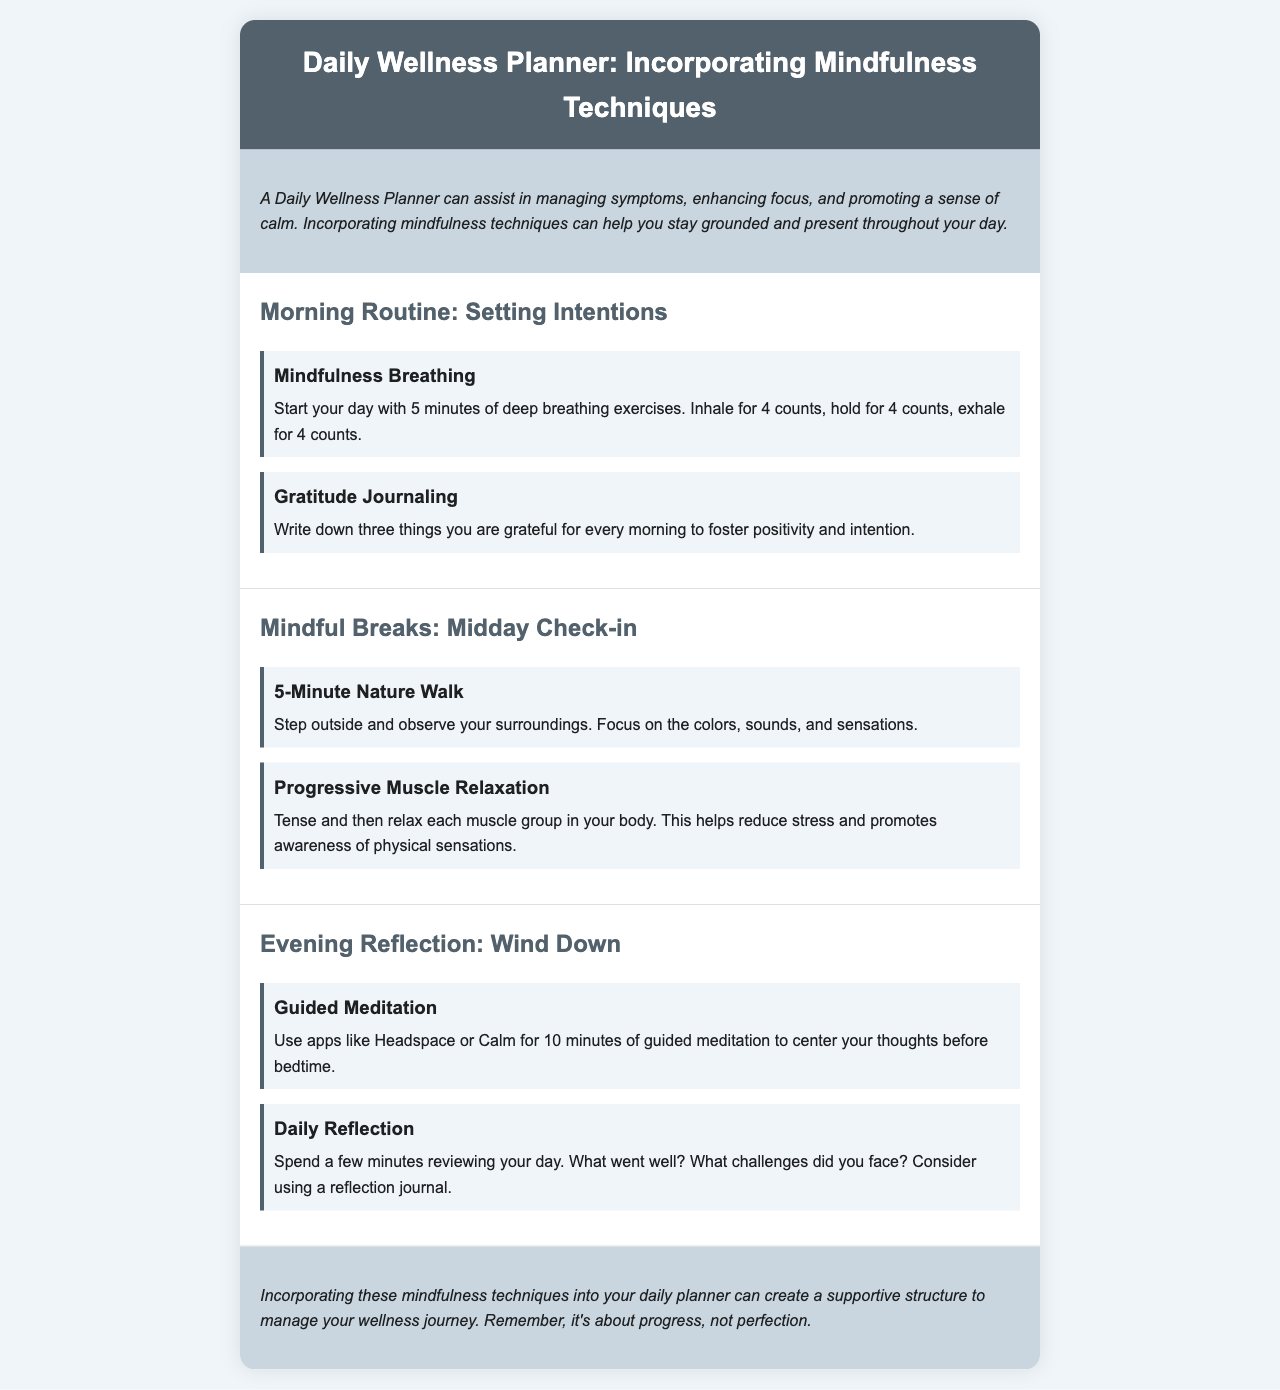What are the two activities included in the Morning Routine? The Morning Routine section lists two activities: Mindfulness Breathing and Gratitude Journaling.
Answer: Mindfulness Breathing, Gratitude Journaling How long should you practice mindfulness breathing? The document specifies that you should start your day with 5 minutes of deep breathing exercises.
Answer: 5 minutes What is one method suggested for Midday Check-in? The Midday Check-in section features activities, including a 5-Minute Nature Walk and Progressive Muscle Relaxation.
Answer: 5-Minute Nature Walk What should you do during the Evening Reflection? The Evening Reflection section encourages you to review your day and consider what went well and what challenges you faced.
Answer: Review your day What is the main purpose of the Daily Wellness Planner? The introduction explains that the Daily Wellness Planner assists in managing symptoms, enhancing focus, and promoting a sense of calm.
Answer: Managing symptoms, enhancing focus, promoting calm 